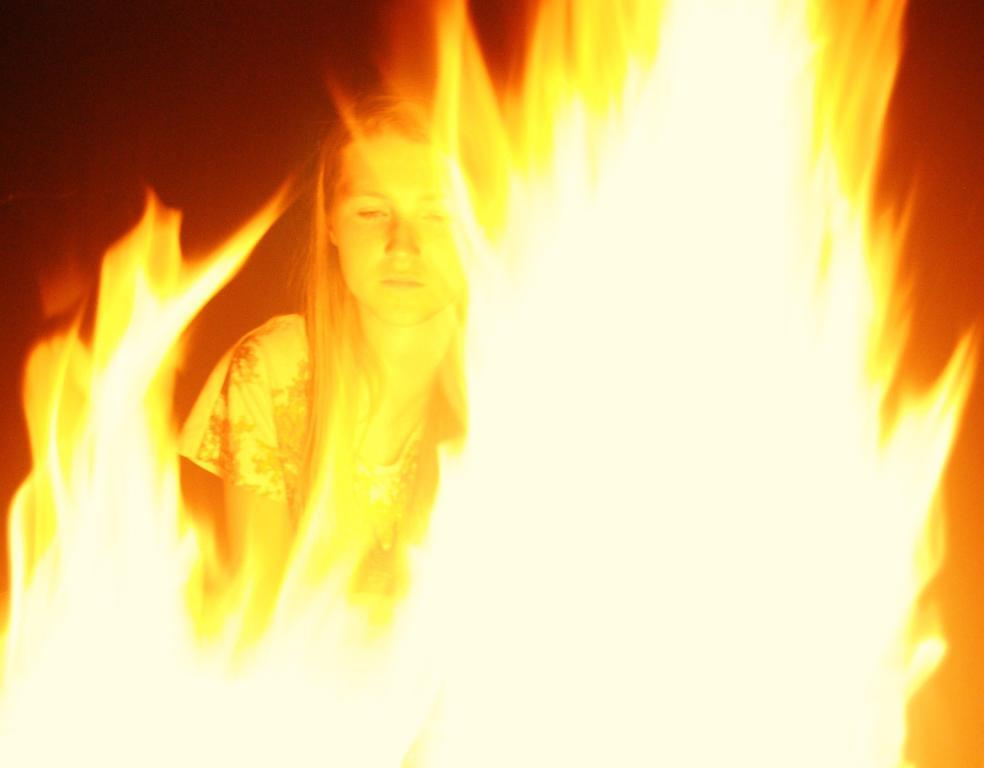Who is present in the image? There is a woman in the image. What can be seen in the foreground of the image? There is fire in the foreground of the image. What type of structure can be seen supporting the frogs in the image? There are no frogs or structures present in the image. What type of approval is the woman seeking in the image? There is no indication in the image that the woman is seeking any approval. 